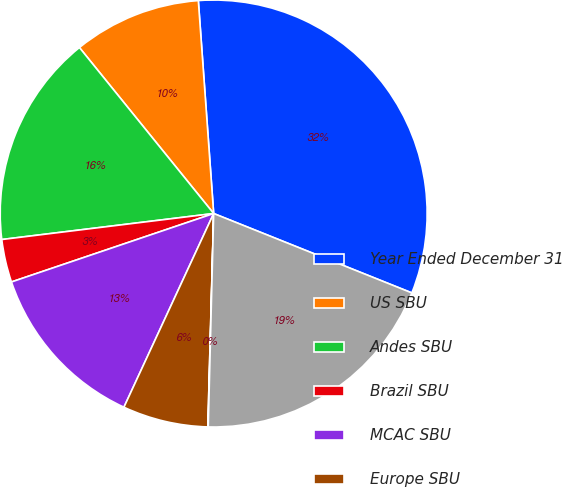<chart> <loc_0><loc_0><loc_500><loc_500><pie_chart><fcel>Year Ended December 31<fcel>US SBU<fcel>Andes SBU<fcel>Brazil SBU<fcel>MCAC SBU<fcel>Europe SBU<fcel>Asia SBU<fcel>Corporate and Other<nl><fcel>32.21%<fcel>9.68%<fcel>16.12%<fcel>3.25%<fcel>12.9%<fcel>6.47%<fcel>0.03%<fcel>19.34%<nl></chart> 